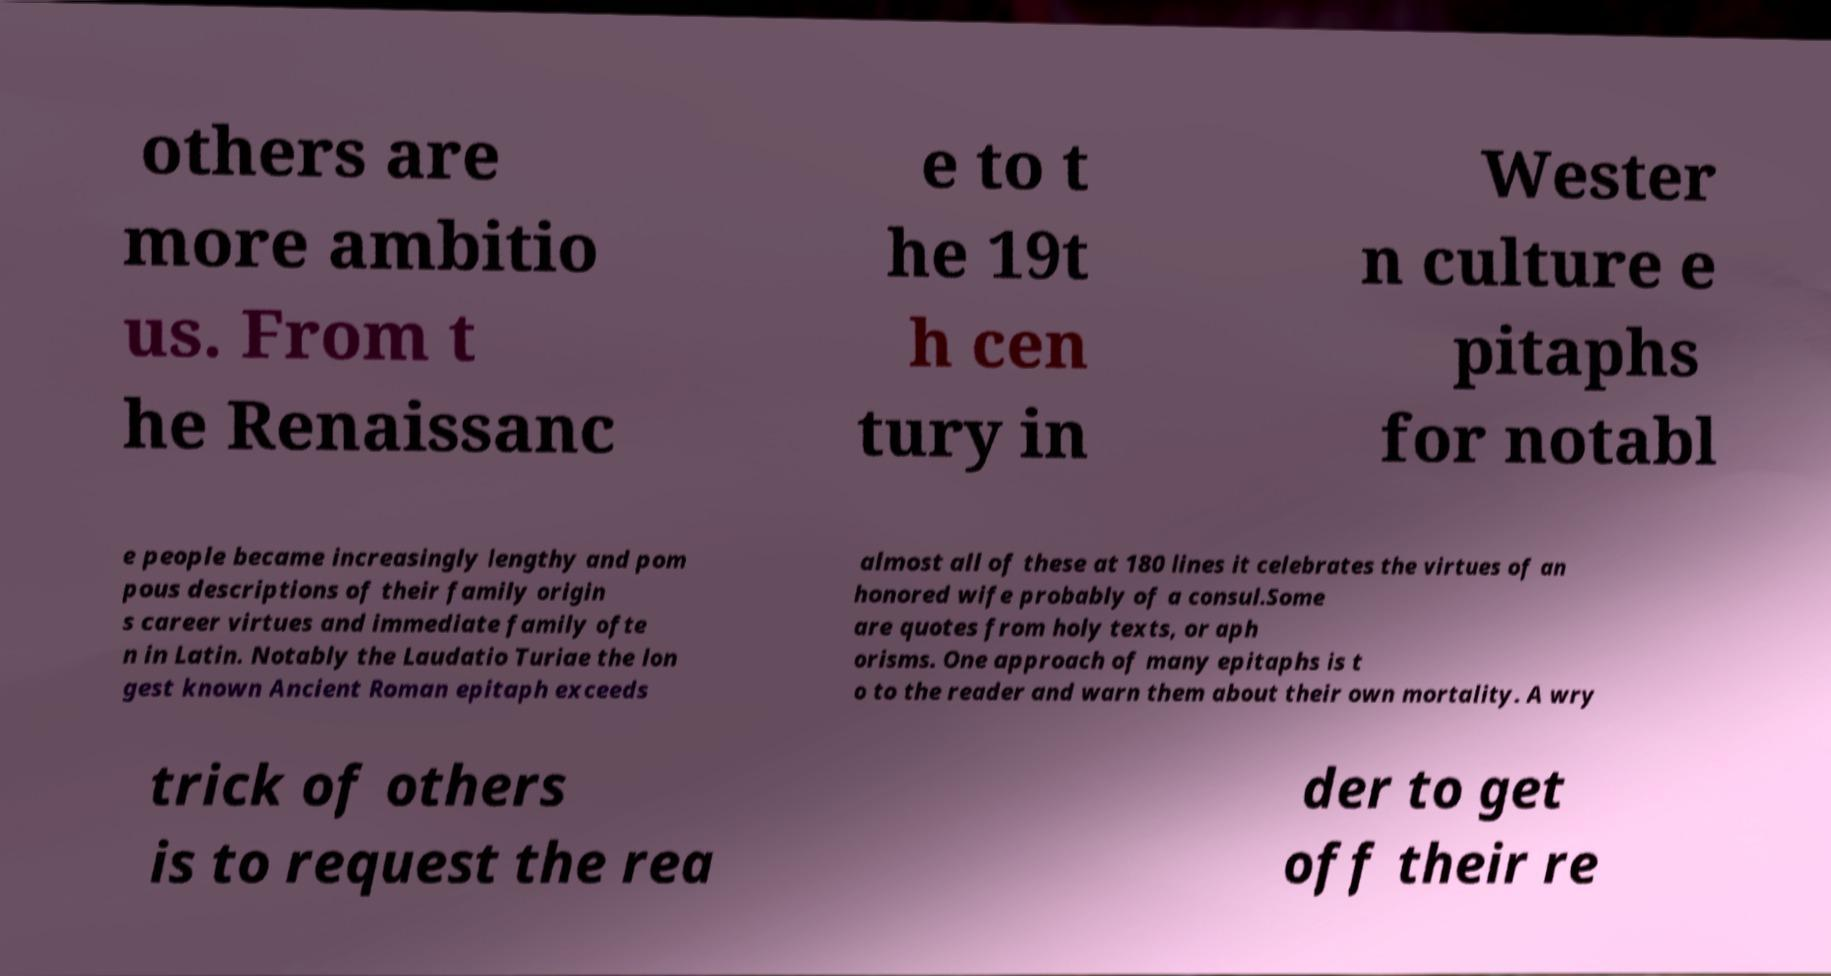Please identify and transcribe the text found in this image. others are more ambitio us. From t he Renaissanc e to t he 19t h cen tury in Wester n culture e pitaphs for notabl e people became increasingly lengthy and pom pous descriptions of their family origin s career virtues and immediate family ofte n in Latin. Notably the Laudatio Turiae the lon gest known Ancient Roman epitaph exceeds almost all of these at 180 lines it celebrates the virtues of an honored wife probably of a consul.Some are quotes from holy texts, or aph orisms. One approach of many epitaphs is t o to the reader and warn them about their own mortality. A wry trick of others is to request the rea der to get off their re 